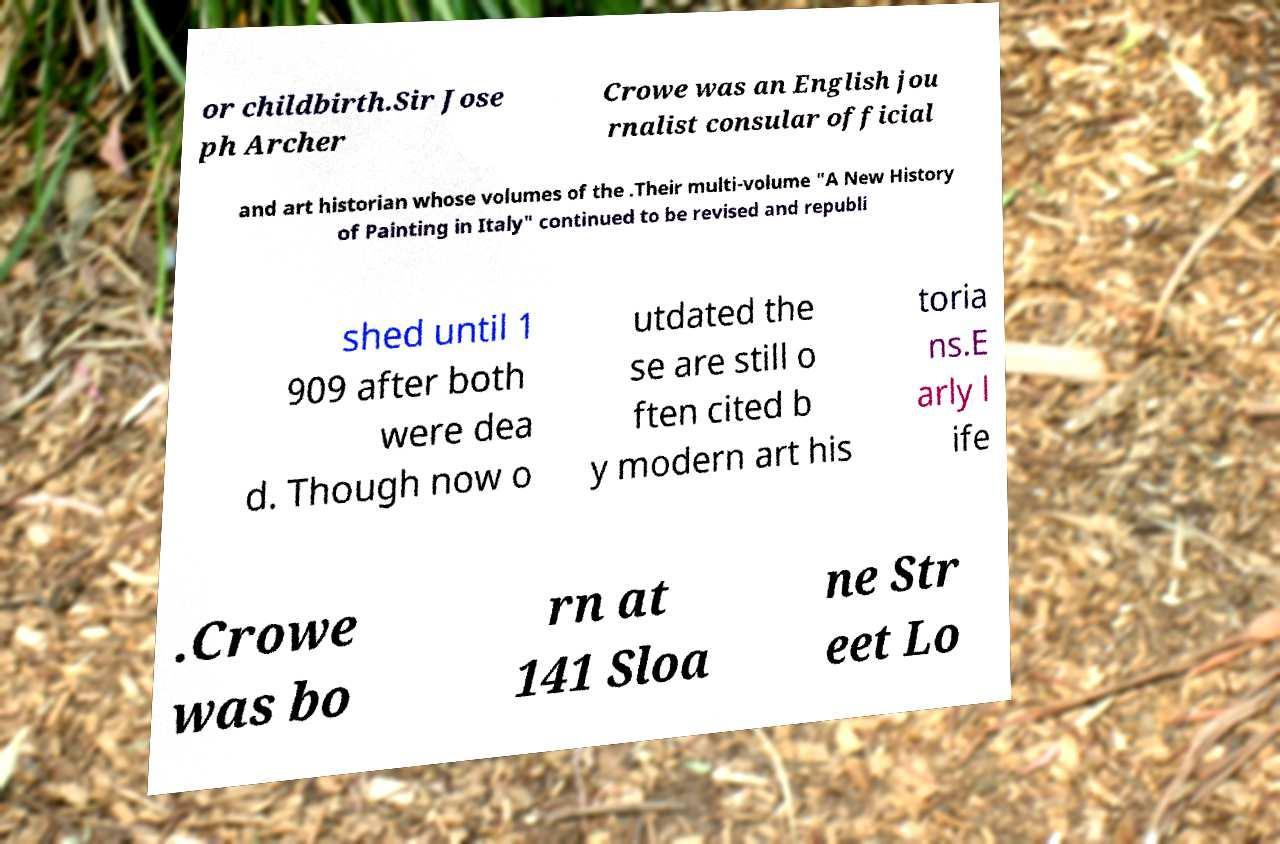Please read and relay the text visible in this image. What does it say? or childbirth.Sir Jose ph Archer Crowe was an English jou rnalist consular official and art historian whose volumes of the .Their multi-volume "A New History of Painting in Italy" continued to be revised and republi shed until 1 909 after both were dea d. Though now o utdated the se are still o ften cited b y modern art his toria ns.E arly l ife .Crowe was bo rn at 141 Sloa ne Str eet Lo 